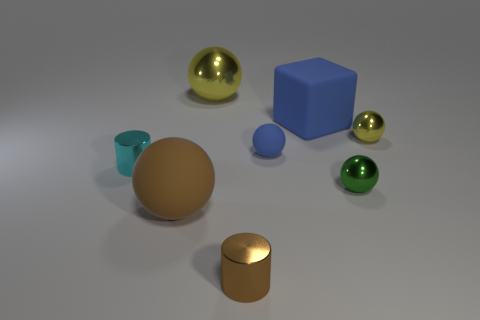Is the size of the green metal thing the same as the brown sphere?
Offer a terse response. No. There is a metal ball that is behind the yellow metallic thing that is on the right side of the large sphere that is behind the large matte sphere; what color is it?
Provide a succinct answer. Yellow. How many metal cylinders are the same color as the large metallic ball?
Offer a very short reply. 0. How many big things are brown cylinders or purple metallic things?
Provide a short and direct response. 0. Is there a tiny brown thing that has the same shape as the large blue rubber object?
Give a very brief answer. No. Is the large brown object the same shape as the small green metal object?
Ensure brevity in your answer.  Yes. There is a cylinder behind the metal cylinder in front of the brown rubber object; what is its color?
Offer a terse response. Cyan. The matte ball that is the same size as the block is what color?
Your answer should be compact. Brown. What number of matte things are yellow objects or large blue blocks?
Provide a succinct answer. 1. What number of shiny balls are behind the cylinder to the left of the brown rubber sphere?
Provide a succinct answer. 2. 